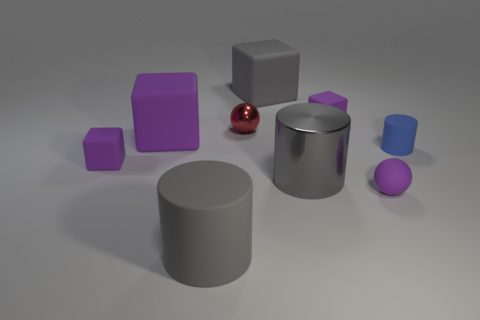Is the material of the purple thing that is behind the tiny red thing the same as the small ball left of the gray metallic cylinder? no 